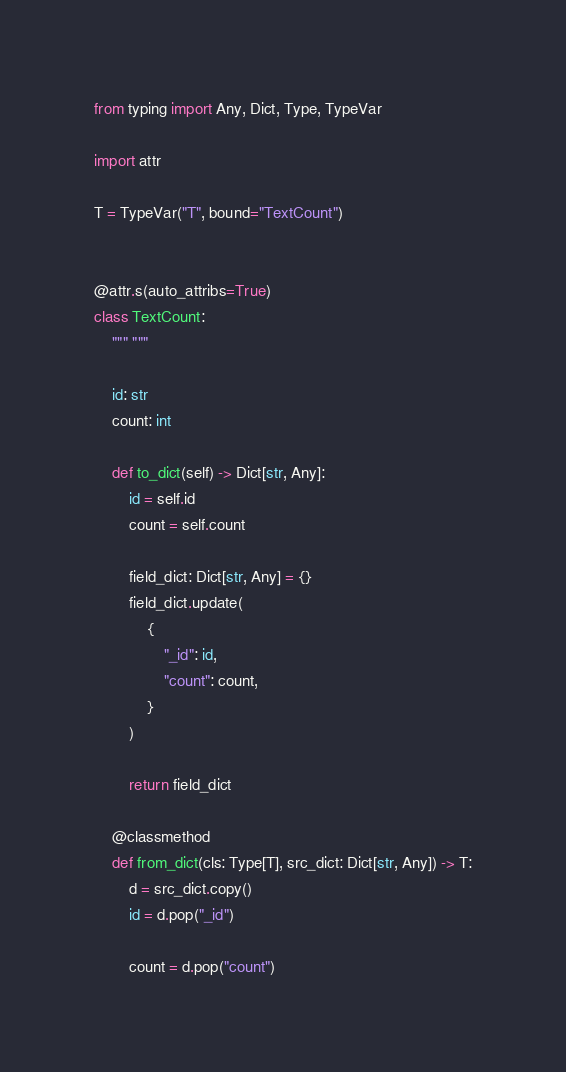Convert code to text. <code><loc_0><loc_0><loc_500><loc_500><_Python_>from typing import Any, Dict, Type, TypeVar

import attr

T = TypeVar("T", bound="TextCount")


@attr.s(auto_attribs=True)
class TextCount:
    """ """

    id: str
    count: int

    def to_dict(self) -> Dict[str, Any]:
        id = self.id
        count = self.count

        field_dict: Dict[str, Any] = {}
        field_dict.update(
            {
                "_id": id,
                "count": count,
            }
        )

        return field_dict

    @classmethod
    def from_dict(cls: Type[T], src_dict: Dict[str, Any]) -> T:
        d = src_dict.copy()
        id = d.pop("_id")

        count = d.pop("count")
</code> 